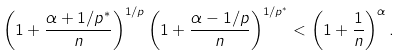Convert formula to latex. <formula><loc_0><loc_0><loc_500><loc_500>\left ( 1 + \frac { \alpha + 1 / p ^ { * } } { n } \right ) ^ { 1 / p } \left ( 1 + \frac { \alpha - 1 / p } { n } \right ) ^ { 1 / p ^ { * } } < \left ( 1 + \frac { 1 } { n } \right ) ^ { \alpha } .</formula> 